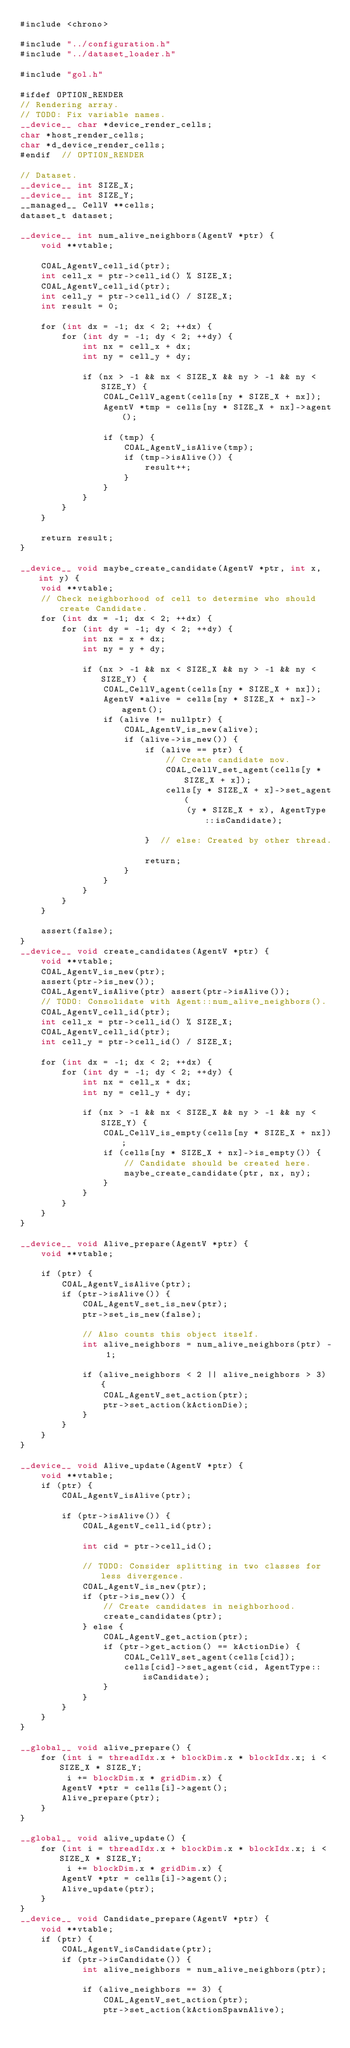<code> <loc_0><loc_0><loc_500><loc_500><_Cuda_>#include <chrono>

#include "../configuration.h"
#include "../dataset_loader.h"

#include "gol.h"

#ifdef OPTION_RENDER
// Rendering array.
// TODO: Fix variable names.
__device__ char *device_render_cells;
char *host_render_cells;
char *d_device_render_cells;
#endif  // OPTION_RENDER

// Dataset.
__device__ int SIZE_X;
__device__ int SIZE_Y;
__managed__ CellV **cells;
dataset_t dataset;

__device__ int num_alive_neighbors(AgentV *ptr) {
    void **vtable;

    COAL_AgentV_cell_id(ptr);
    int cell_x = ptr->cell_id() % SIZE_X;
    COAL_AgentV_cell_id(ptr);
    int cell_y = ptr->cell_id() / SIZE_X;
    int result = 0;

    for (int dx = -1; dx < 2; ++dx) {
        for (int dy = -1; dy < 2; ++dy) {
            int nx = cell_x + dx;
            int ny = cell_y + dy;

            if (nx > -1 && nx < SIZE_X && ny > -1 && ny < SIZE_Y) {
                COAL_CellV_agent(cells[ny * SIZE_X + nx]);
                AgentV *tmp = cells[ny * SIZE_X + nx]->agent();

                if (tmp) {
                    COAL_AgentV_isAlive(tmp);
                    if (tmp->isAlive()) {
                        result++;
                    }
                }
            }
        }
    }

    return result;
}

__device__ void maybe_create_candidate(AgentV *ptr, int x, int y) {
    void **vtable;
    // Check neighborhood of cell to determine who should create Candidate.
    for (int dx = -1; dx < 2; ++dx) {
        for (int dy = -1; dy < 2; ++dy) {
            int nx = x + dx;
            int ny = y + dy;

            if (nx > -1 && nx < SIZE_X && ny > -1 && ny < SIZE_Y) {
                COAL_CellV_agent(cells[ny * SIZE_X + nx]);
                AgentV *alive = cells[ny * SIZE_X + nx]->agent();
                if (alive != nullptr) {
                    COAL_AgentV_is_new(alive);
                    if (alive->is_new()) {
                        if (alive == ptr) {
                            // Create candidate now.
                            COAL_CellV_set_agent(cells[y * SIZE_X + x]);
                            cells[y * SIZE_X + x]->set_agent(
                                (y * SIZE_X + x), AgentType::isCandidate);

                        }  // else: Created by other thread.

                        return;
                    }
                }
            }
        }
    }

    assert(false);
}
__device__ void create_candidates(AgentV *ptr) {
    void **vtable;
    COAL_AgentV_is_new(ptr);
    assert(ptr->is_new());
    COAL_AgentV_isAlive(ptr) assert(ptr->isAlive());
    // TODO: Consolidate with Agent::num_alive_neighbors().
    COAL_AgentV_cell_id(ptr);
    int cell_x = ptr->cell_id() % SIZE_X;
    COAL_AgentV_cell_id(ptr);
    int cell_y = ptr->cell_id() / SIZE_X;

    for (int dx = -1; dx < 2; ++dx) {
        for (int dy = -1; dy < 2; ++dy) {
            int nx = cell_x + dx;
            int ny = cell_y + dy;

            if (nx > -1 && nx < SIZE_X && ny > -1 && ny < SIZE_Y) {
                COAL_CellV_is_empty(cells[ny * SIZE_X + nx]);
                if (cells[ny * SIZE_X + nx]->is_empty()) {
                    // Candidate should be created here.
                    maybe_create_candidate(ptr, nx, ny);
                }
            }
        }
    }
}

__device__ void Alive_prepare(AgentV *ptr) {
    void **vtable;

    if (ptr) {
        COAL_AgentV_isAlive(ptr);
        if (ptr->isAlive()) {
            COAL_AgentV_set_is_new(ptr);
            ptr->set_is_new(false);

            // Also counts this object itself.
            int alive_neighbors = num_alive_neighbors(ptr) - 1;

            if (alive_neighbors < 2 || alive_neighbors > 3) {
                COAL_AgentV_set_action(ptr);
                ptr->set_action(kActionDie);
            }
        }
    }
}

__device__ void Alive_update(AgentV *ptr) {
    void **vtable;
    if (ptr) {
        COAL_AgentV_isAlive(ptr);

        if (ptr->isAlive()) {
            COAL_AgentV_cell_id(ptr);

            int cid = ptr->cell_id();

            // TODO: Consider splitting in two classes for less divergence.
            COAL_AgentV_is_new(ptr);
            if (ptr->is_new()) {
                // Create candidates in neighborhood.
                create_candidates(ptr);
            } else {
                COAL_AgentV_get_action(ptr);
                if (ptr->get_action() == kActionDie) {
                    COAL_CellV_set_agent(cells[cid]);
                    cells[cid]->set_agent(cid, AgentType::isCandidate);
                }
            }
        }
    }
}

__global__ void alive_prepare() {
    for (int i = threadIdx.x + blockDim.x * blockIdx.x; i < SIZE_X * SIZE_Y;
         i += blockDim.x * gridDim.x) {
        AgentV *ptr = cells[i]->agent();
        Alive_prepare(ptr);
    }
}

__global__ void alive_update() {
    for (int i = threadIdx.x + blockDim.x * blockIdx.x; i < SIZE_X * SIZE_Y;
         i += blockDim.x * gridDim.x) {
        AgentV *ptr = cells[i]->agent();
        Alive_update(ptr);
    }
}
__device__ void Candidate_prepare(AgentV *ptr) {
    void **vtable;
    if (ptr) {
        COAL_AgentV_isCandidate(ptr);
        if (ptr->isCandidate()) {
            int alive_neighbors = num_alive_neighbors(ptr);

            if (alive_neighbors == 3) {
                COAL_AgentV_set_action(ptr);
                ptr->set_action(kActionSpawnAlive);
</code> 